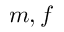<formula> <loc_0><loc_0><loc_500><loc_500>m , f</formula> 